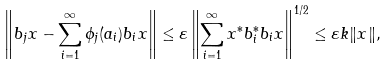Convert formula to latex. <formula><loc_0><loc_0><loc_500><loc_500>\left \| b _ { j } x - \sum ^ { \infty } _ { i = 1 } \phi _ { j } ( a _ { i } ) b _ { i } x \right \| \leq \varepsilon \left \| \sum ^ { \infty } _ { i = 1 } x ^ { * } b ^ { * } _ { i } b _ { i } x \right \| ^ { 1 / 2 } \leq \varepsilon k \| x \| ,</formula> 